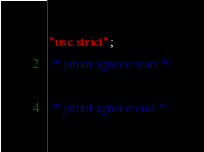Convert code to text. <code><loc_0><loc_0><loc_500><loc_500><_JavaScript_>"use strict";
/* jshint ignore:start */

/* jshint ignore:end */
</code> 